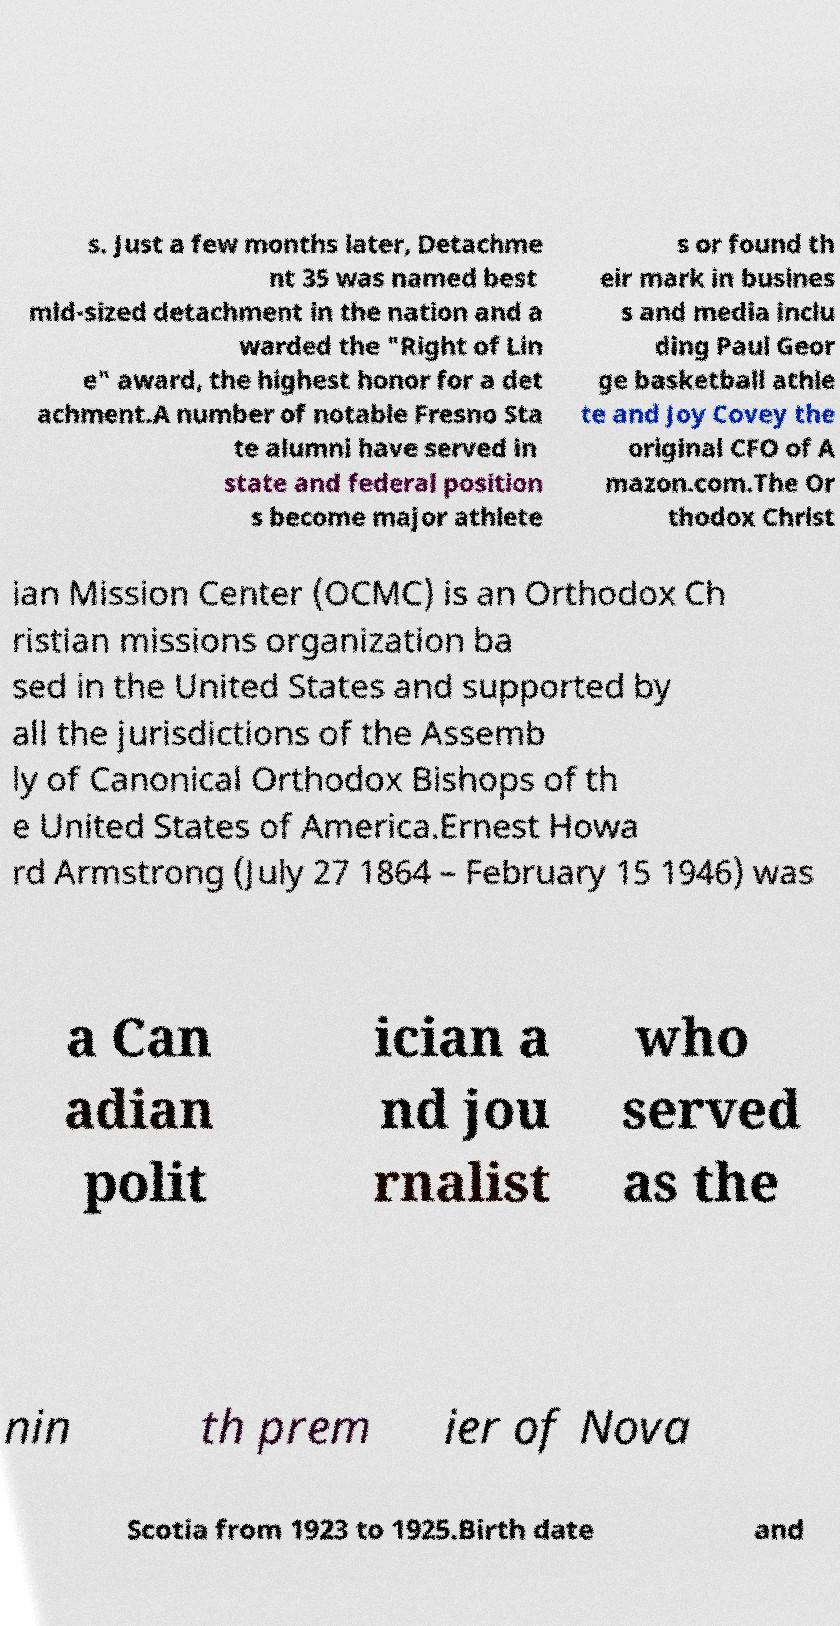Please read and relay the text visible in this image. What does it say? s. Just a few months later, Detachme nt 35 was named best mid-sized detachment in the nation and a warded the "Right of Lin e" award, the highest honor for a det achment.A number of notable Fresno Sta te alumni have served in state and federal position s become major athlete s or found th eir mark in busines s and media inclu ding Paul Geor ge basketball athle te and Joy Covey the original CFO of A mazon.com.The Or thodox Christ ian Mission Center (OCMC) is an Orthodox Ch ristian missions organization ba sed in the United States and supported by all the jurisdictions of the Assemb ly of Canonical Orthodox Bishops of th e United States of America.Ernest Howa rd Armstrong (July 27 1864 – February 15 1946) was a Can adian polit ician a nd jou rnalist who served as the nin th prem ier of Nova Scotia from 1923 to 1925.Birth date and 